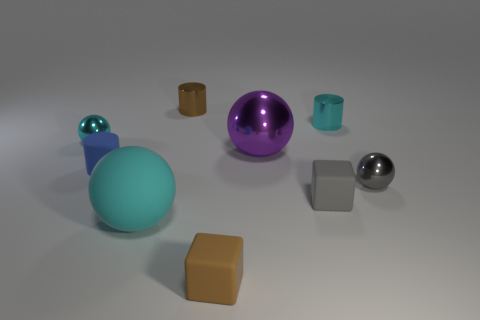Add 1 small cylinders. How many objects exist? 10 Subtract all cylinders. How many objects are left? 6 Add 2 tiny brown balls. How many tiny brown balls exist? 2 Subtract 0 red blocks. How many objects are left? 9 Subtract all tiny red spheres. Subtract all tiny blue objects. How many objects are left? 8 Add 8 tiny cubes. How many tiny cubes are left? 10 